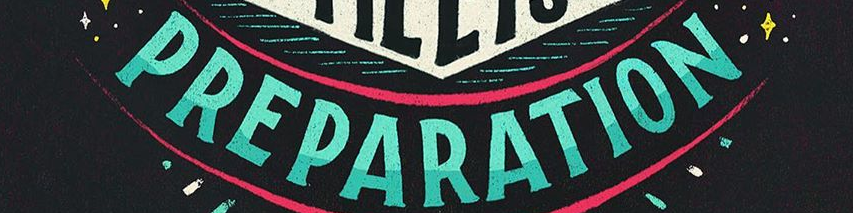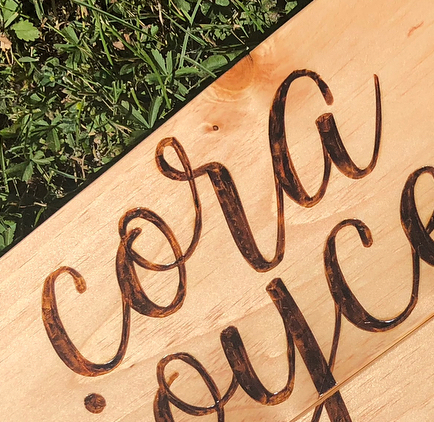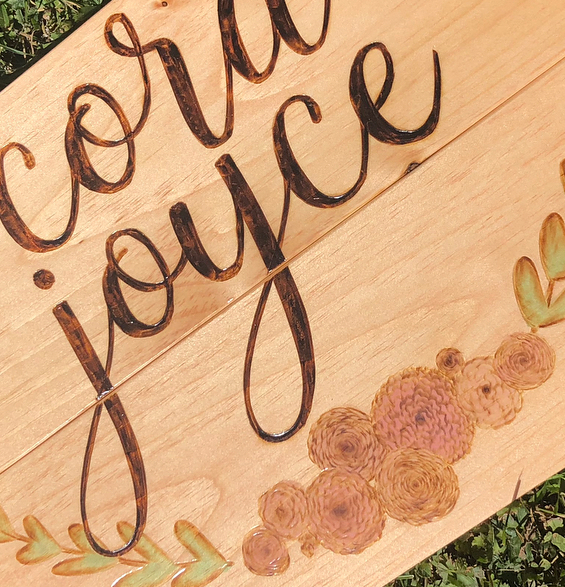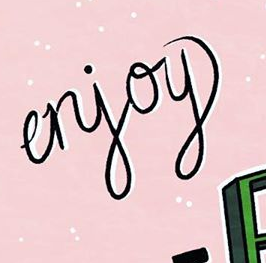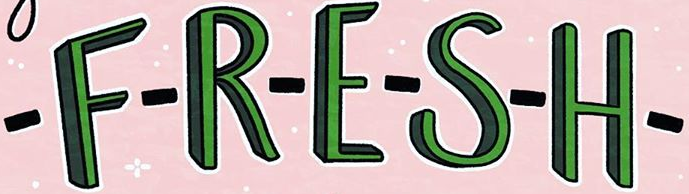What text appears in these images from left to right, separated by a semicolon? PREPARATION; cora; joyce; erjoy; -F-R-E-S-H- 